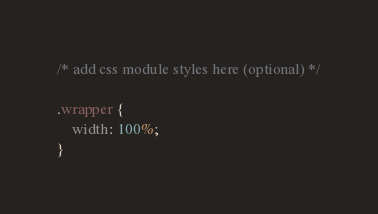Convert code to text. <code><loc_0><loc_0><loc_500><loc_500><_CSS_>/* add css module styles here (optional) */

.wrapper {
	width: 100%;
}
</code> 